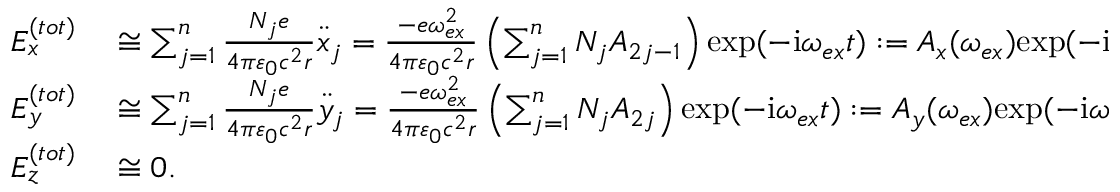Convert formula to latex. <formula><loc_0><loc_0><loc_500><loc_500>\begin{array} { r l } { E _ { x } ^ { ( t o t ) } } & \cong \sum _ { j = 1 } ^ { n } \frac { N _ { j } e } { 4 \pi \varepsilon _ { 0 } c ^ { 2 } r } \ddot { x } _ { j } = \frac { - e \omega _ { e x } ^ { 2 } } { 4 \pi \varepsilon _ { 0 } c ^ { 2 } r } \left ( \sum _ { j = 1 } ^ { n } N _ { j } A _ { 2 j - 1 } \right ) e x p ( - i \omega _ { e x } t ) \colon = A _ { x } ( \omega _ { e x } ) e x p ( - i \omega _ { e x } t ) , } \\ { E _ { y } ^ { ( t o t ) } } & \cong \sum _ { j = 1 } ^ { n } \frac { N _ { j } e } { 4 \pi \varepsilon _ { 0 } c ^ { 2 } r } \ddot { y } _ { j } = \frac { - e \omega _ { e x } ^ { 2 } } { 4 \pi \varepsilon _ { 0 } c ^ { 2 } r } \left ( \sum _ { j = 1 } ^ { n } N _ { j } A _ { 2 j } \right ) e x p ( - i \omega _ { e x } t ) \colon = A _ { y } ( \omega _ { e x } ) e x p ( - i \omega _ { e x } t ) , } \\ { E _ { z } ^ { ( t o t ) } } & \cong 0 . } \end{array}</formula> 